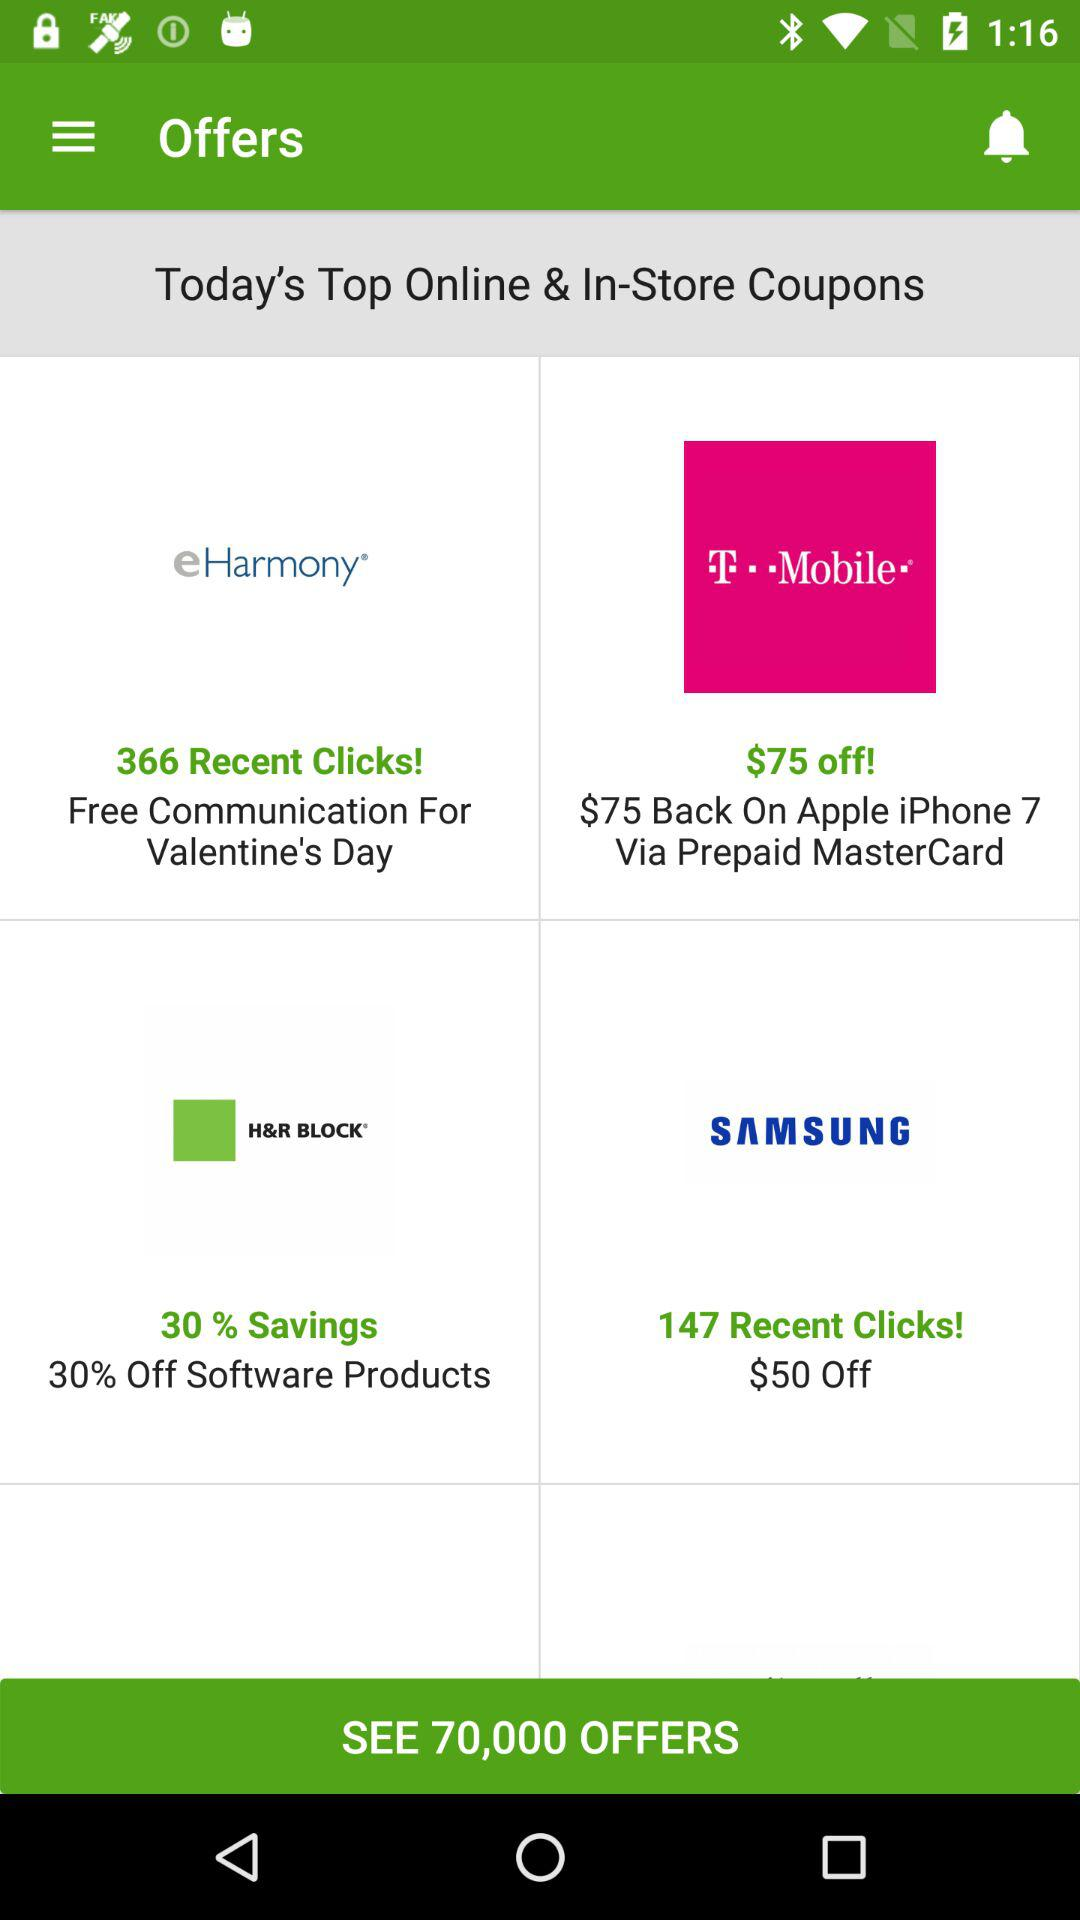How many offers are available? The available offers are 70,000. 